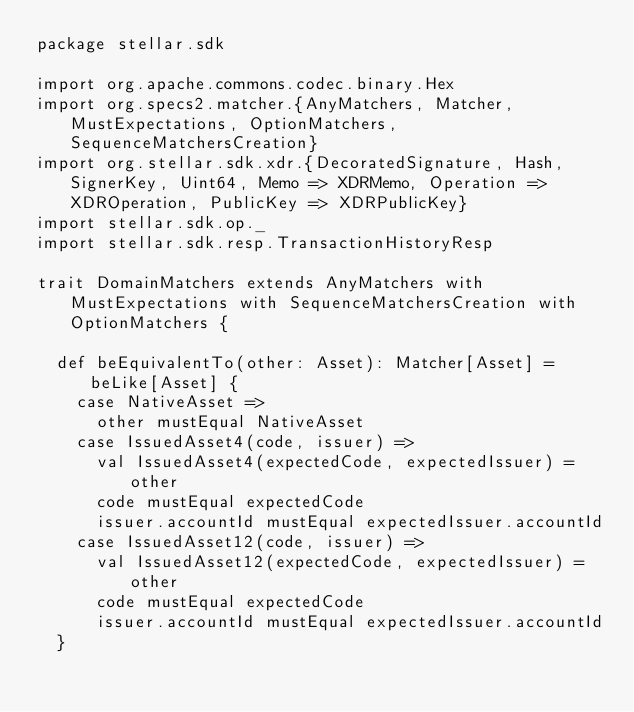Convert code to text. <code><loc_0><loc_0><loc_500><loc_500><_Scala_>package stellar.sdk

import org.apache.commons.codec.binary.Hex
import org.specs2.matcher.{AnyMatchers, Matcher, MustExpectations, OptionMatchers, SequenceMatchersCreation}
import org.stellar.sdk.xdr.{DecoratedSignature, Hash, SignerKey, Uint64, Memo => XDRMemo, Operation => XDROperation, PublicKey => XDRPublicKey}
import stellar.sdk.op._
import stellar.sdk.resp.TransactionHistoryResp

trait DomainMatchers extends AnyMatchers with MustExpectations with SequenceMatchersCreation with OptionMatchers {

  def beEquivalentTo(other: Asset): Matcher[Asset] = beLike[Asset] {
    case NativeAsset =>
      other mustEqual NativeAsset
    case IssuedAsset4(code, issuer) =>
      val IssuedAsset4(expectedCode, expectedIssuer) = other
      code mustEqual expectedCode
      issuer.accountId mustEqual expectedIssuer.accountId
    case IssuedAsset12(code, issuer) =>
      val IssuedAsset12(expectedCode, expectedIssuer) = other
      code mustEqual expectedCode
      issuer.accountId mustEqual expectedIssuer.accountId
  }
</code> 